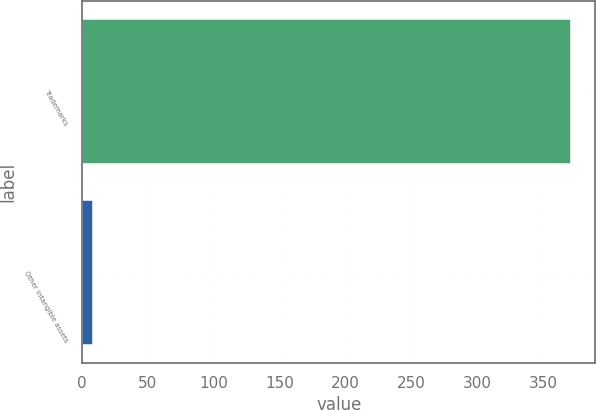Convert chart to OTSL. <chart><loc_0><loc_0><loc_500><loc_500><bar_chart><fcel>Trademarks<fcel>Other intangible assets<nl><fcel>371.3<fcel>8.3<nl></chart> 